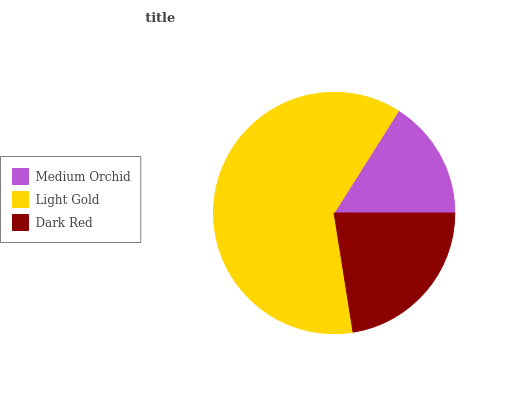Is Medium Orchid the minimum?
Answer yes or no. Yes. Is Light Gold the maximum?
Answer yes or no. Yes. Is Dark Red the minimum?
Answer yes or no. No. Is Dark Red the maximum?
Answer yes or no. No. Is Light Gold greater than Dark Red?
Answer yes or no. Yes. Is Dark Red less than Light Gold?
Answer yes or no. Yes. Is Dark Red greater than Light Gold?
Answer yes or no. No. Is Light Gold less than Dark Red?
Answer yes or no. No. Is Dark Red the high median?
Answer yes or no. Yes. Is Dark Red the low median?
Answer yes or no. Yes. Is Medium Orchid the high median?
Answer yes or no. No. Is Medium Orchid the low median?
Answer yes or no. No. 